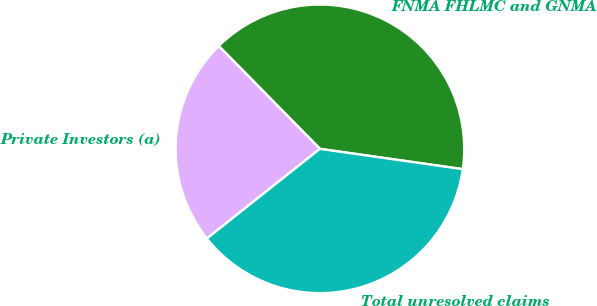Convert chart. <chart><loc_0><loc_0><loc_500><loc_500><pie_chart><fcel>FNMA FHLMC and GNMA<fcel>Private Investors (a)<fcel>Total unresolved claims<nl><fcel>39.62%<fcel>23.31%<fcel>37.08%<nl></chart> 